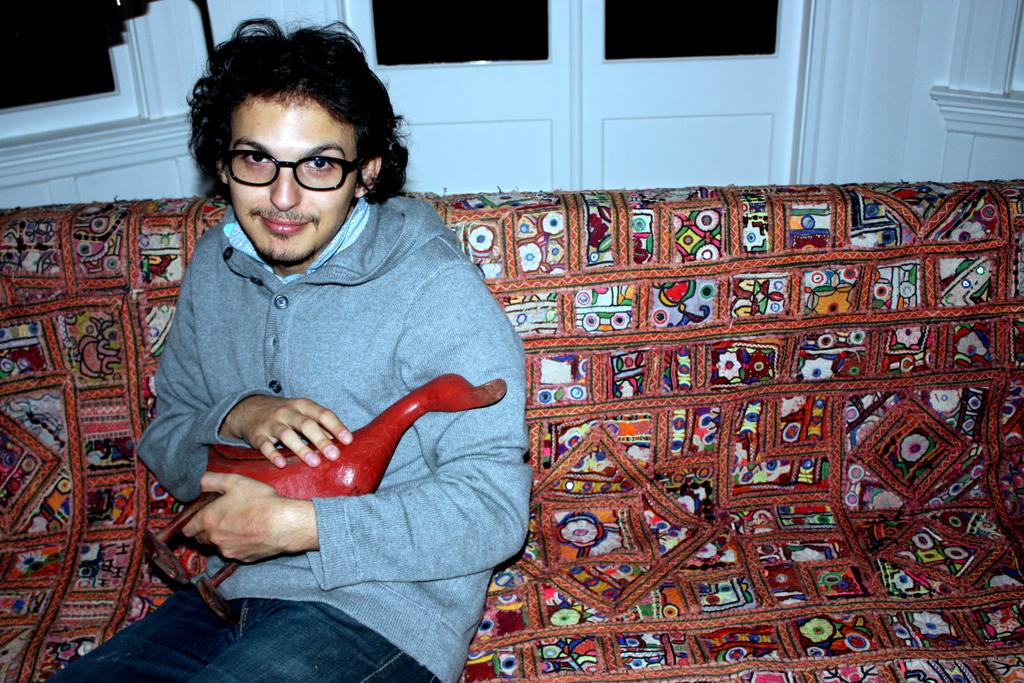What is the man in the image doing? The man is sitting on the sofa. What object is the man holding in the image? The man is holding a wooden duck. What can be seen in the background of the image? There are doors and a wall visible in the background. What type of sail can be seen on the wooden duck in the image? There is no sail present on the wooden duck in the image; it is a stationary object. 